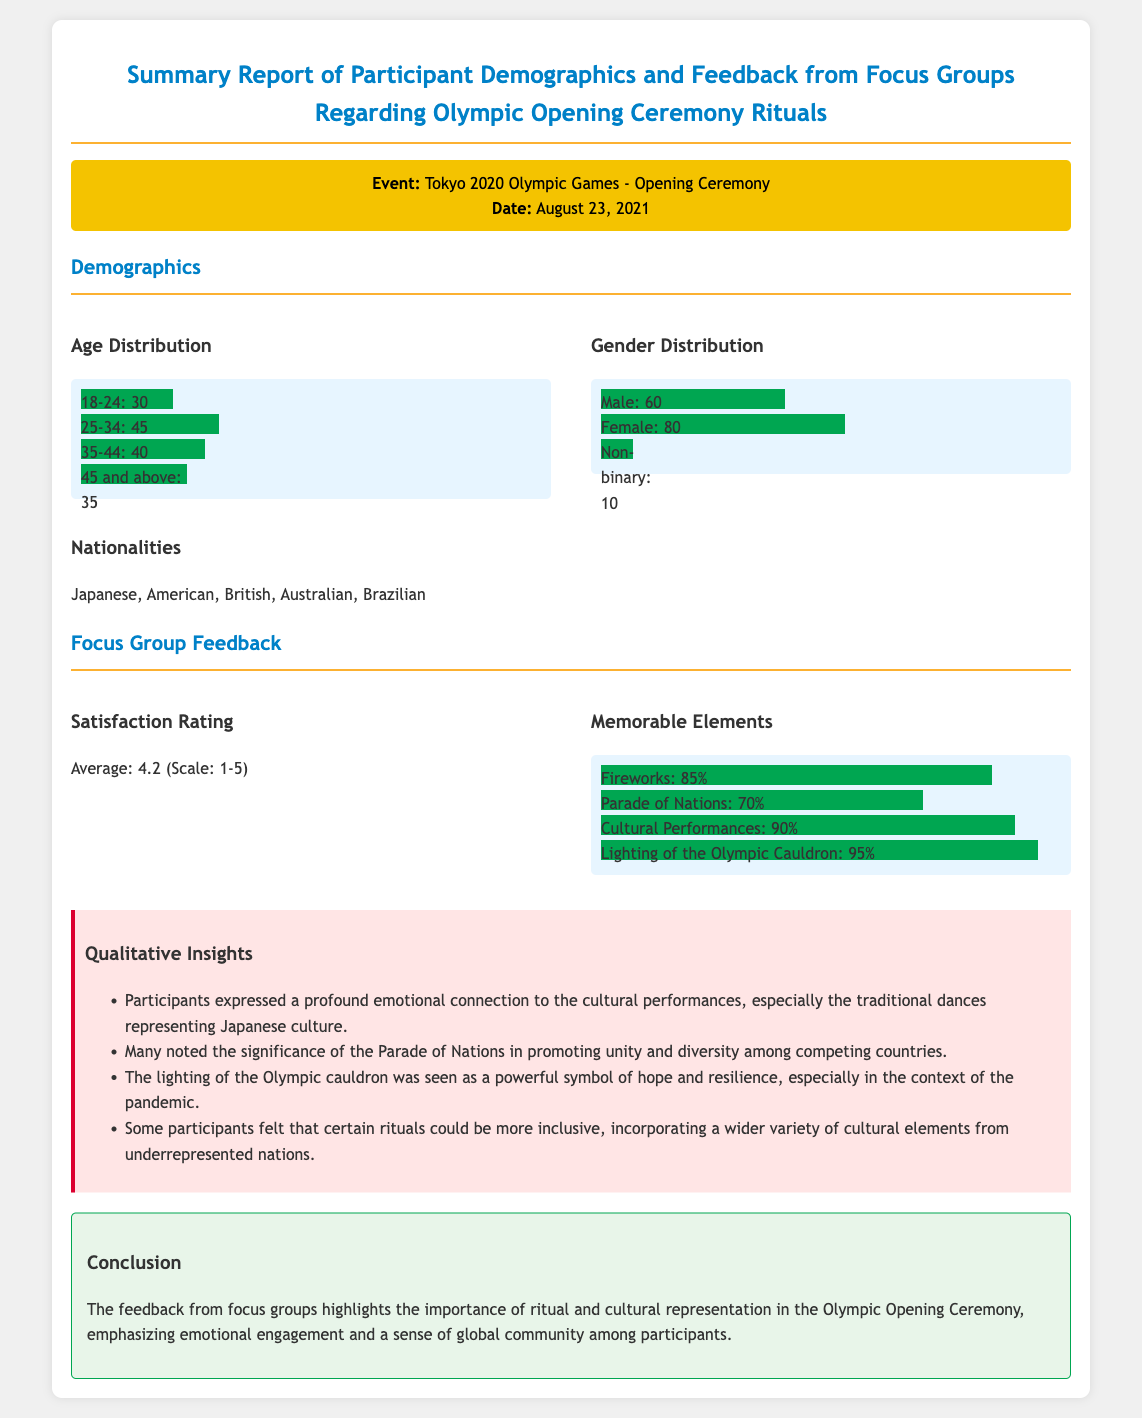What was the date of the Olympic Opening Ceremony? The date of the Olympic Opening Ceremony was explicitly stated in the document.
Answer: August 23, 2021 What is the average satisfaction rating from the focus groups? The average satisfaction rating is provided on a scale of 1-5, indicating participant feedback.
Answer: 4.2 How many participants were represented in the 25-34 age group? The specific number of participants in the age group is provided in the Age Distribution section.
Answer: 45 Which element received the highest percentage of memorable recognition? The chart details the memorable elements and their recognition percentages among participants.
Answer: Lighting of the Olympic Cauldron: 95% What cultural performance received significant emotional connection from participants? The qualitative insights highlight specific cultural elements participants connected with emotionally.
Answer: Traditional dances representing Japanese culture How does the feedback describe the significance of the Parade of Nations? The qualitative insights “Unity and diversity among competing countries” provides reasoning for its importance.
Answer: Promoting unity and diversity What demographic distribution has the highest representation in gender? The Gender Distribution section lists each group's count, indicating representation.
Answer: Female: 80 What countries are listed in the nationalities of participants? The document specifies nationalities from which participants were drawn, creating an inclusive perspective.
Answer: Japanese, American, British, Australian, Brazilian 